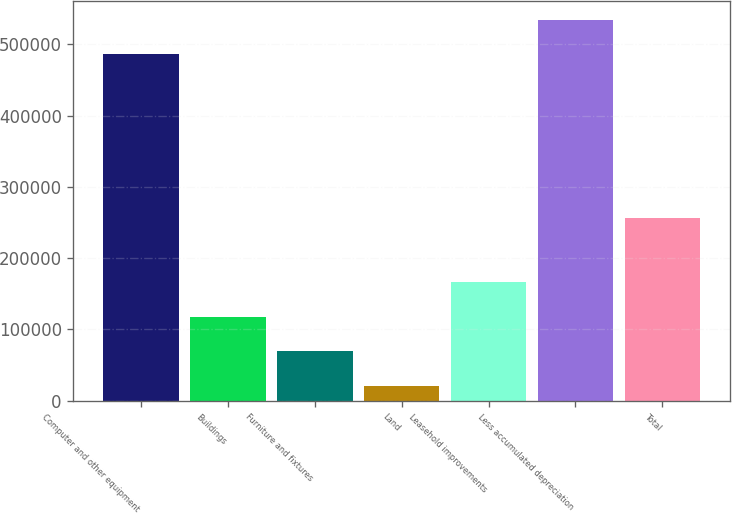Convert chart to OTSL. <chart><loc_0><loc_0><loc_500><loc_500><bar_chart><fcel>Computer and other equipment<fcel>Buildings<fcel>Furniture and fixtures<fcel>Land<fcel>Leasehold improvements<fcel>Less accumulated depreciation<fcel>Total<nl><fcel>486109<fcel>117540<fcel>68977<fcel>20414<fcel>166103<fcel>534672<fcel>257035<nl></chart> 